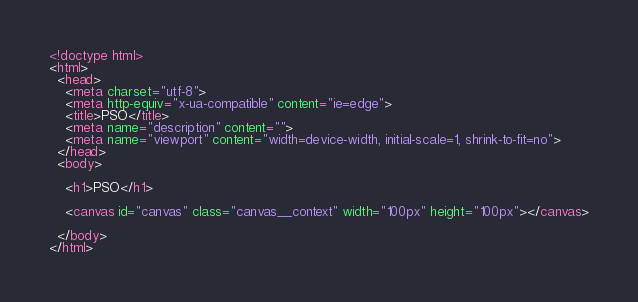<code> <loc_0><loc_0><loc_500><loc_500><_HTML_><!doctype html>
<html>
  <head>
    <meta charset="utf-8">
    <meta http-equiv="x-ua-compatible" content="ie=edge">
    <title>PSO</title>
    <meta name="description" content="">
    <meta name="viewport" content="width=device-width, initial-scale=1, shrink-to-fit=no">
  </head>
  <body>
    
    <h1>PSO</h1>

    <canvas id="canvas" class="canvas__context" width="100px" height="100px"></canvas>

  </body>
</html></code> 